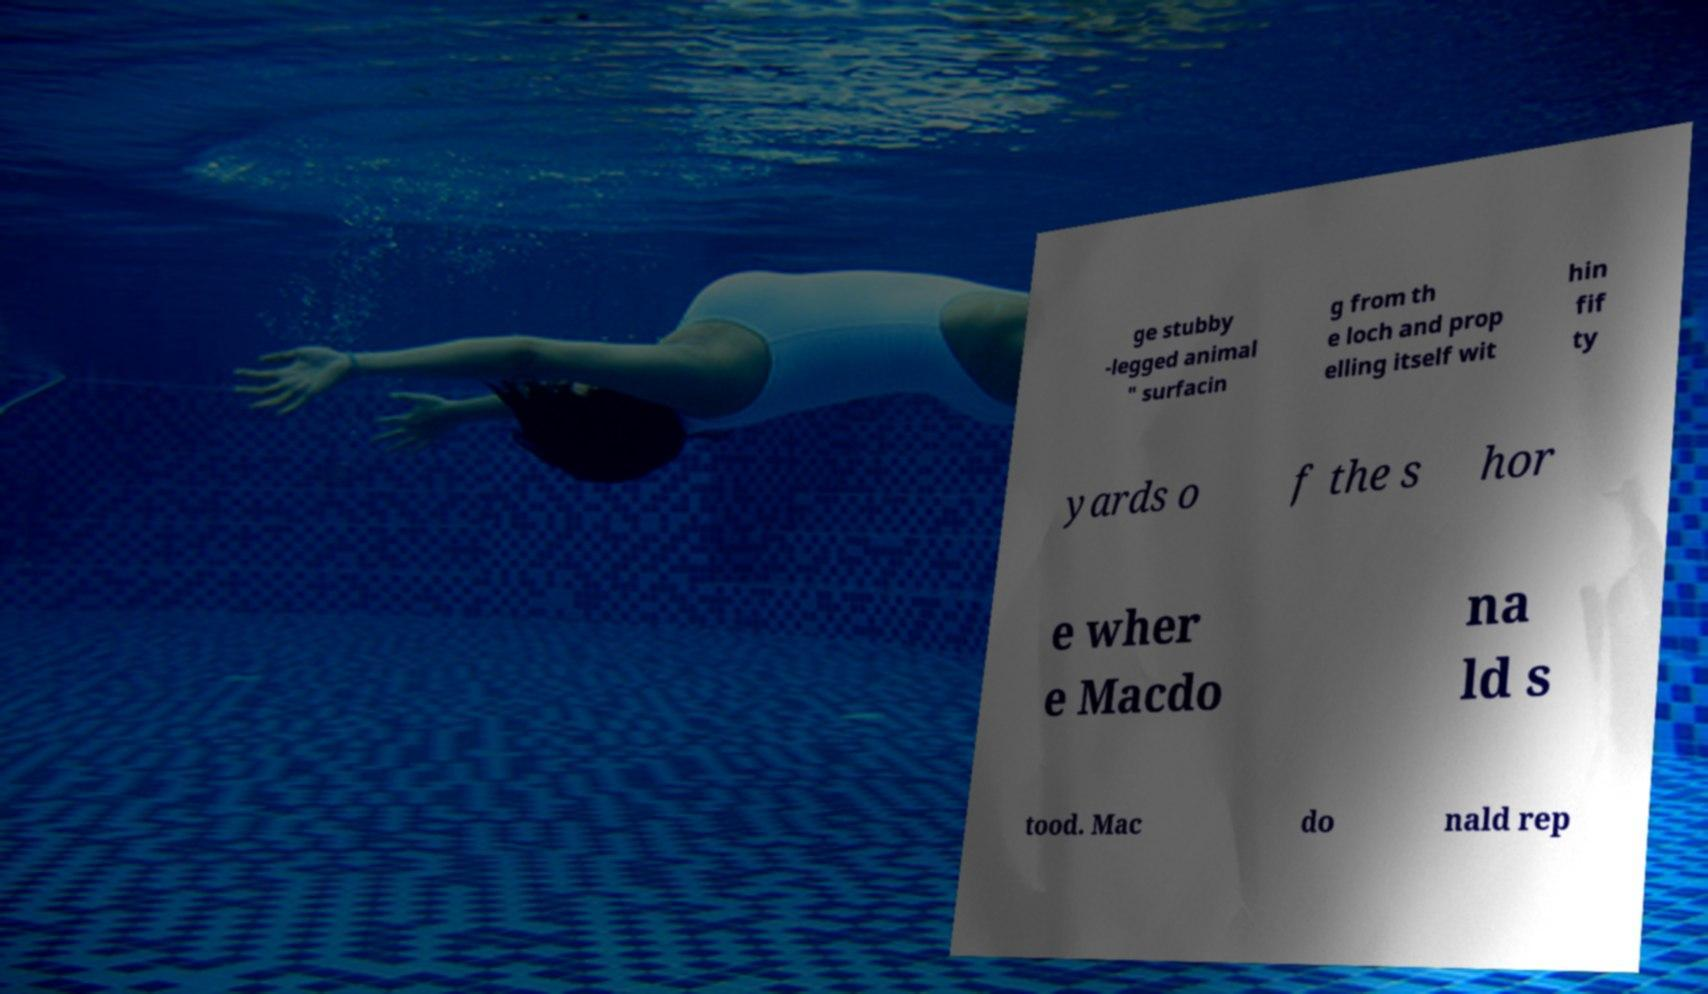Can you read and provide the text displayed in the image?This photo seems to have some interesting text. Can you extract and type it out for me? ge stubby -legged animal " surfacin g from th e loch and prop elling itself wit hin fif ty yards o f the s hor e wher e Macdo na ld s tood. Mac do nald rep 